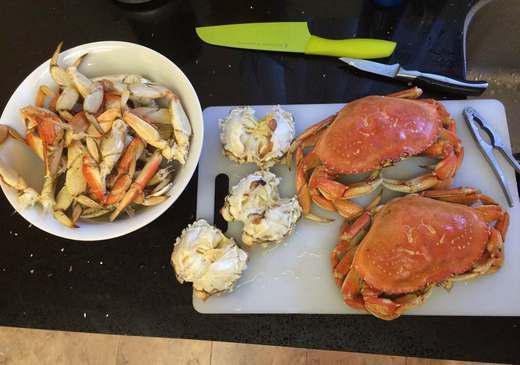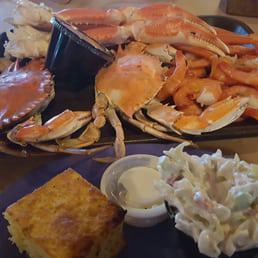The first image is the image on the left, the second image is the image on the right. Given the left and right images, does the statement "there is crab ready to serve with a wedge of lemon next to it" hold true? Answer yes or no. No. The first image is the image on the left, the second image is the image on the right. Considering the images on both sides, is "In at least one image there is a single cooked crab upside down exposing it's soft parts." valid? Answer yes or no. No. 